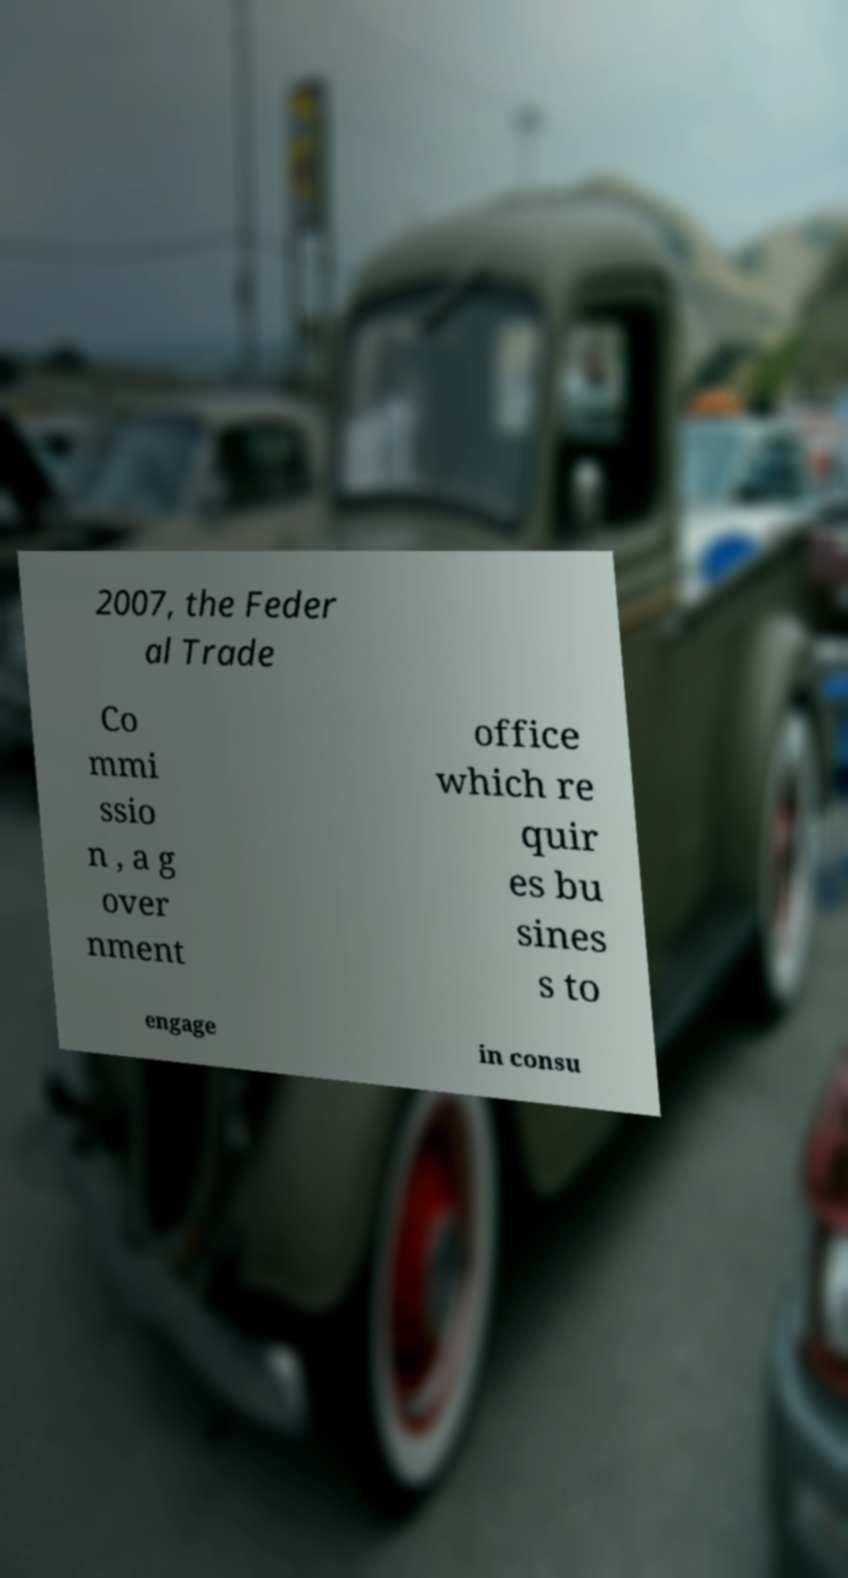There's text embedded in this image that I need extracted. Can you transcribe it verbatim? 2007, the Feder al Trade Co mmi ssio n , a g over nment office which re quir es bu sines s to engage in consu 